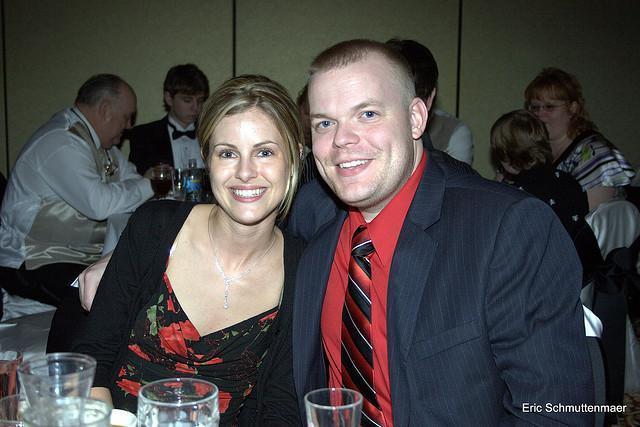How many glasses are set?
Give a very brief answer. 4. How many glasses of wine has he had?
Give a very brief answer. 1. How many people are there?
Give a very brief answer. 7. How many cups are there?
Give a very brief answer. 2. 